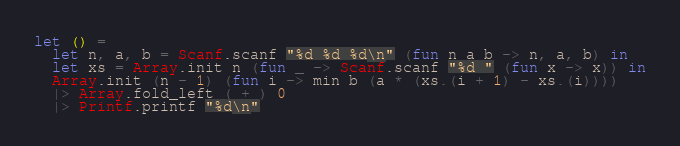<code> <loc_0><loc_0><loc_500><loc_500><_OCaml_>let () =
  let n, a, b = Scanf.scanf "%d %d %d\n" (fun n a b -> n, a, b) in
  let xs = Array.init n (fun _ -> Scanf.scanf "%d " (fun x -> x)) in
  Array.init (n - 1) (fun i -> min b (a * (xs.(i + 1) - xs.(i))))
  |> Array.fold_left ( + ) 0
  |> Printf.printf "%d\n"</code> 